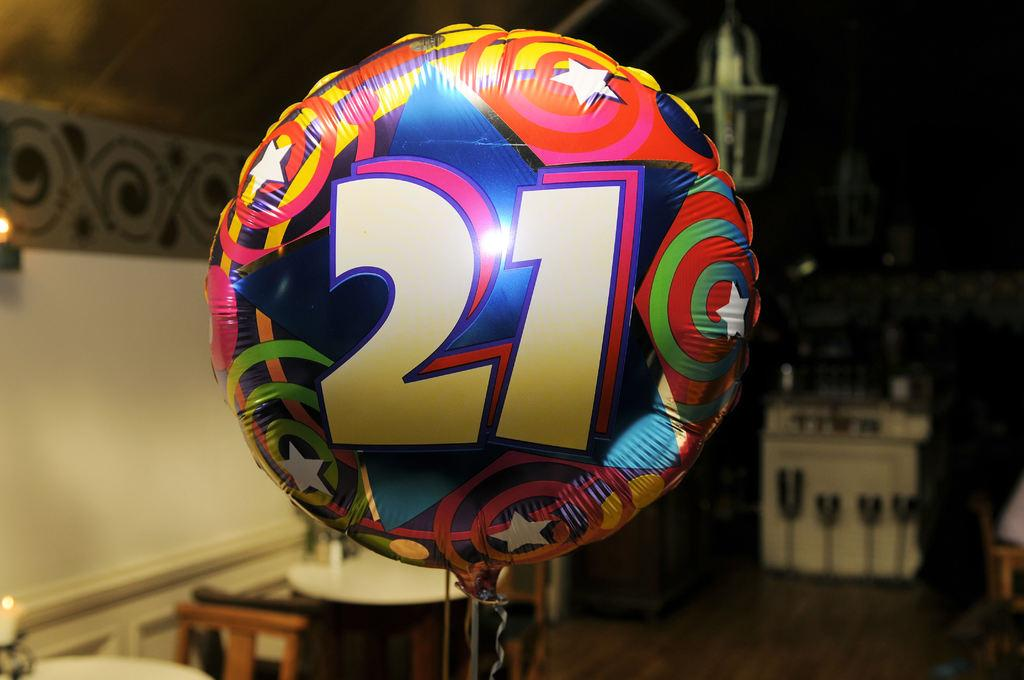What is the main subject of the image? The main subject of the image is an air balloon. Can you describe the appearance of the air balloon? The air balloon has different colors. Is there any specific detail on the air balloon? Yes, there is a number 21 on the air balloon. What can be seen at the bottom of the image? There are chairs and tables at the bottom of the image. What is located on the left side of the image? There is a wall on the left side of the image. What type of fang can be seen on the air balloon in the image? There are no fangs present on the air balloon in the image. What thing is being used to hold the air balloon in the image? The image does not show any specific object or thing being used to hold the air balloon. 